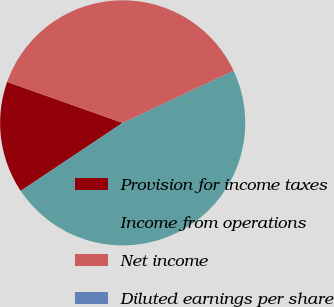<chart> <loc_0><loc_0><loc_500><loc_500><pie_chart><fcel>Provision for income taxes<fcel>Income from operations<fcel>Net income<fcel>Diluted earnings per share<nl><fcel>14.79%<fcel>47.64%<fcel>37.57%<fcel>0.0%<nl></chart> 